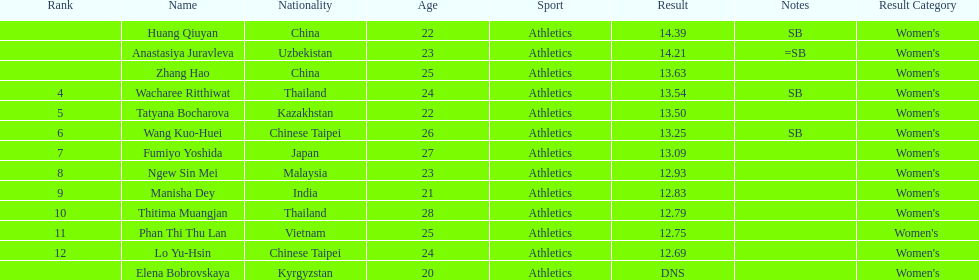How many athletes had a better result than tatyana bocharova? 4. 